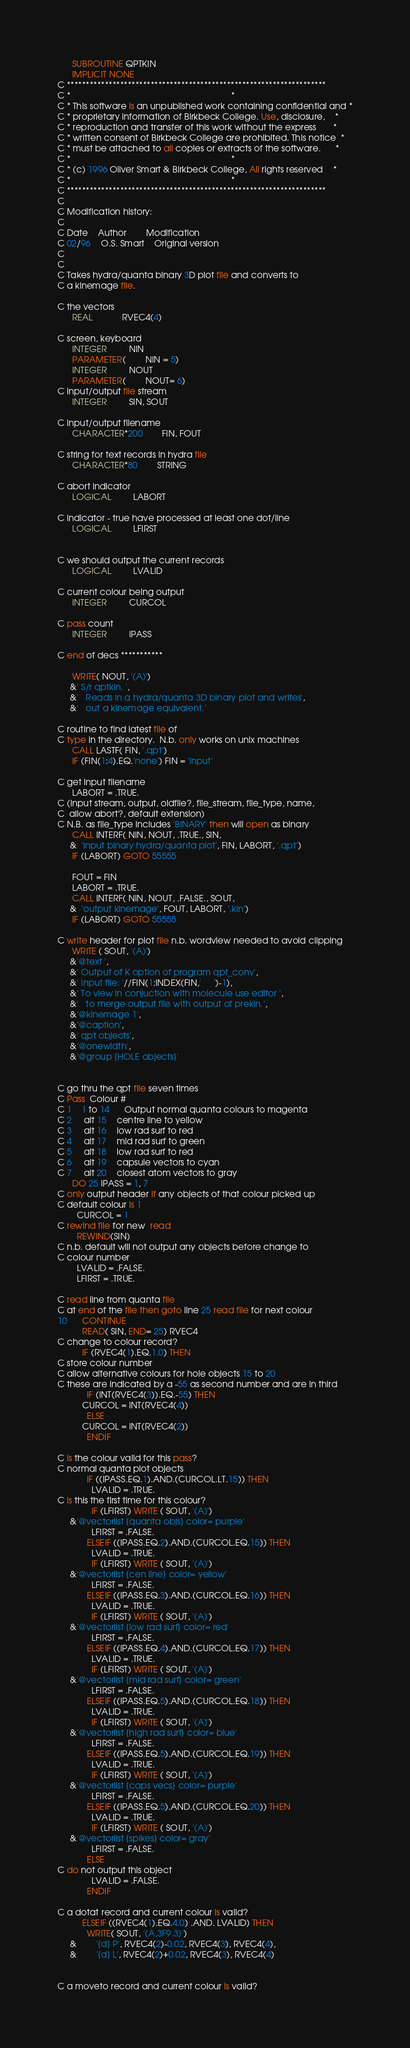<code> <loc_0><loc_0><loc_500><loc_500><_FORTRAN_>      SUBROUTINE QPTKIN
      IMPLICIT NONE
C ********************************************************************
C *                                                                  *
C * This software is an unpublished work containing confidential and *
C * proprietary information of Birkbeck College. Use, disclosure,    *
C * reproduction and transfer of this work without the express       *
C * written consent of Birkbeck College are prohibited. This notice  *
C * must be attached to all copies or extracts of the software.      *
C *                                                                  *
C * (c) 1996 Oliver Smart & Birkbeck College, All rights reserved    *
C *                                                                  *
C ********************************************************************
C
C Modification history:
C
C Date	Author		Modification
C 02/96	O.S. Smart	Original version
C
C
C Takes hydra/quanta binary 3D plot file and converts to
C a kinemage file.

C the vectors
      REAL 			RVEC4(4)

C screen, keyboard
      INTEGER			NIN
      PARAMETER(		NIN = 5)
      INTEGER			NOUT
      PARAMETER(		NOUT= 6)
C input/output file stream
      INTEGER			SIN, SOUT

C input/output filename
      CHARACTER*200		FIN, FOUT

C string for text records in hydra file
      CHARACTER*80		STRING

C abort indicator
      LOGICAL			LABORT

C indicator - true have processed at least one dot/line
      LOGICAL			LFIRST


C we should output the current records
      LOGICAL			LVALID

C current colour being output
      INTEGER			CURCOL

C pass count
      INTEGER			IPASS

C end of decs ***********

      WRITE( NOUT, '(A)') 
     &' S/r qptkin. ',
     &'   Reads in a hydra/quanta 3D binary plot and writes',
     &'   out a kinemage equivalent.'

C routine to find latest file of
C type in the directory.  N.b. only works on unix machines
      CALL LASTF( FIN, '.qpt')
      IF (FIN(1:4).EQ.'none') FIN = 'input'

C get input filename
      LABORT = .TRUE.
C (input stream, output, oldfile?, file_stream, file_type, name,
C  allow abort?, default extension)
C N.B. as file_type includes 'BINARY' then will open as binary
      CALL INTERF( NIN, NOUT, .TRUE., SIN, 
     &  'input binary hydra/quanta plot', FIN, LABORT, '.qpt')
      IF (LABORT) GOTO 55555

      FOUT = FIN
      LABORT = .TRUE.
      CALL INTERF( NIN, NOUT, .FALSE., SOUT, 
     &  'output kinemage', FOUT, LABORT, '.kin')
      IF (LABORT) GOTO 55555

C write header for plot file n.b. wordview needed to avoid clipping
      WRITE ( SOUT, '(A)') 
     &'@text ',
     &' Output of K option of program qpt_conv',
     &' Input file: '//FIN(1:INDEX(FIN,'     ')-1),
     &' To view in conjuction with molecule use editor ',
     &'   to merge output file with output of prekin.',
     &'@kinemage 1',
     &'@caption',
     &' qpt objects',
     &'@onewidth',
     &'@group {HOLE objects}'


C go thru the qpt file seven times
C Pass  Colour #
C 1 	1 to 14	  Output normal quanta colours to magenta
C 2     alt 15    centre line to yellow 
C 3     alt 16    low rad surf to red
C 4     alt 17    mid rad surf to green
C 5     alt 18    low rad surf to red
C 6     alt 19    capsule vectors to cyan
C 7     alt 20    closest atom vectors to gray
      DO 25 IPASS = 1, 7
C only output header if any objects of that colour picked up
C default colour is 1
        CURCOL = 1
C rewind file for new  read
        REWIND(SIN)
C n.b. default will not output any objects before change to
C colour number
        LVALID = .FALSE.
        LFIRST = .TRUE.

C read line from quanta file
C at end of the file then goto line 25 read file for next colour 
10      CONTINUE
          READ( SIN, END= 25) RVEC4
C change to colour record?
          IF (RVEC4(1).EQ.1.0) THEN
C store colour number
C allow alternative colours for hole objects 15 to 20
C these are indicated by a -55 as second number and are in third
            IF (INT(RVEC4(3)).EQ.-55) THEN
	      CURCOL = INT(RVEC4(4))
            ELSE
	      CURCOL = INT(RVEC4(2))
            ENDIF

C is the colour valid for this pass?
C normal quanta plot objects
            IF ((IPASS.EQ.1).AND.(CURCOL.LT.15)) THEN
              LVALID = .TRUE.
C is this the first time for this colour?
              IF (LFIRST) WRITE ( SOUT, '(A)') 
     &'@vectorlist {quanta objs} color= purple'
              LFIRST = .FALSE.
            ELSEIF ((IPASS.EQ.2).AND.(CURCOL.EQ.15)) THEN
              LVALID = .TRUE.
              IF (LFIRST) WRITE ( SOUT, '(A)') 
     &'@vectorlist {cen line} color= yellow'
              LFIRST = .FALSE.                                 
            ELSEIF ((IPASS.EQ.3).AND.(CURCOL.EQ.16)) THEN
              LVALID = .TRUE.
              IF (LFIRST) WRITE ( SOUT, '(A)') 
     &'@vectorlist {low rad surf} color= red'
              LFIRST = .FALSE.
            ELSEIF ((IPASS.EQ.4).AND.(CURCOL.EQ.17)) THEN
              LVALID = .TRUE.
              IF (LFIRST) WRITE ( SOUT, '(A)') 
     &'@vectorlist {mid rad surf} color= green'
              LFIRST = .FALSE.
            ELSEIF ((IPASS.EQ.5).AND.(CURCOL.EQ.18)) THEN
              LVALID = .TRUE.
              IF (LFIRST) WRITE ( SOUT, '(A)')
     &'@vectorlist {high rad surf} color= blue'
              LFIRST = .FALSE.
            ELSEIF ((IPASS.EQ.5).AND.(CURCOL.EQ.19)) THEN
              LVALID = .TRUE.
              IF (LFIRST) WRITE ( SOUT, '(A)')
     &'@vectorlist {caps vecs} color= purple'
              LFIRST = .FALSE.
            ELSEIF ((IPASS.EQ.5).AND.(CURCOL.EQ.20)) THEN
              LVALID = .TRUE.
              IF (LFIRST) WRITE ( SOUT, '(A)') 
     &'@vectorlist {spikes} color= gray'
              LFIRST = .FALSE.                                 
            ELSE
C do not output this object
              LVALID = .FALSE.
            ENDIF

C a dotat record and current colour is valid?
          ELSEIF ((RVEC4(1).EQ.4.0) .AND. LVALID) THEN
            WRITE( SOUT, '(A,3F9.3)') 
     &        '{d} P', RVEC4(2)-0.02, RVEC4(3), RVEC4(4),
     &        '{d} L', RVEC4(2)+0.02, RVEC4(3), RVEC4(4)


C a moveto record and current colour is valid?</code> 